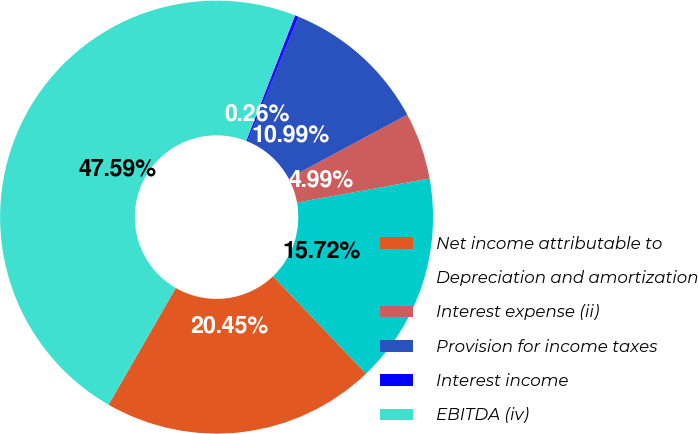<chart> <loc_0><loc_0><loc_500><loc_500><pie_chart><fcel>Net income attributable to<fcel>Depreciation and amortization<fcel>Interest expense (ii)<fcel>Provision for income taxes<fcel>Interest income<fcel>EBITDA (iv)<nl><fcel>20.45%<fcel>15.72%<fcel>4.99%<fcel>10.99%<fcel>0.26%<fcel>47.59%<nl></chart> 